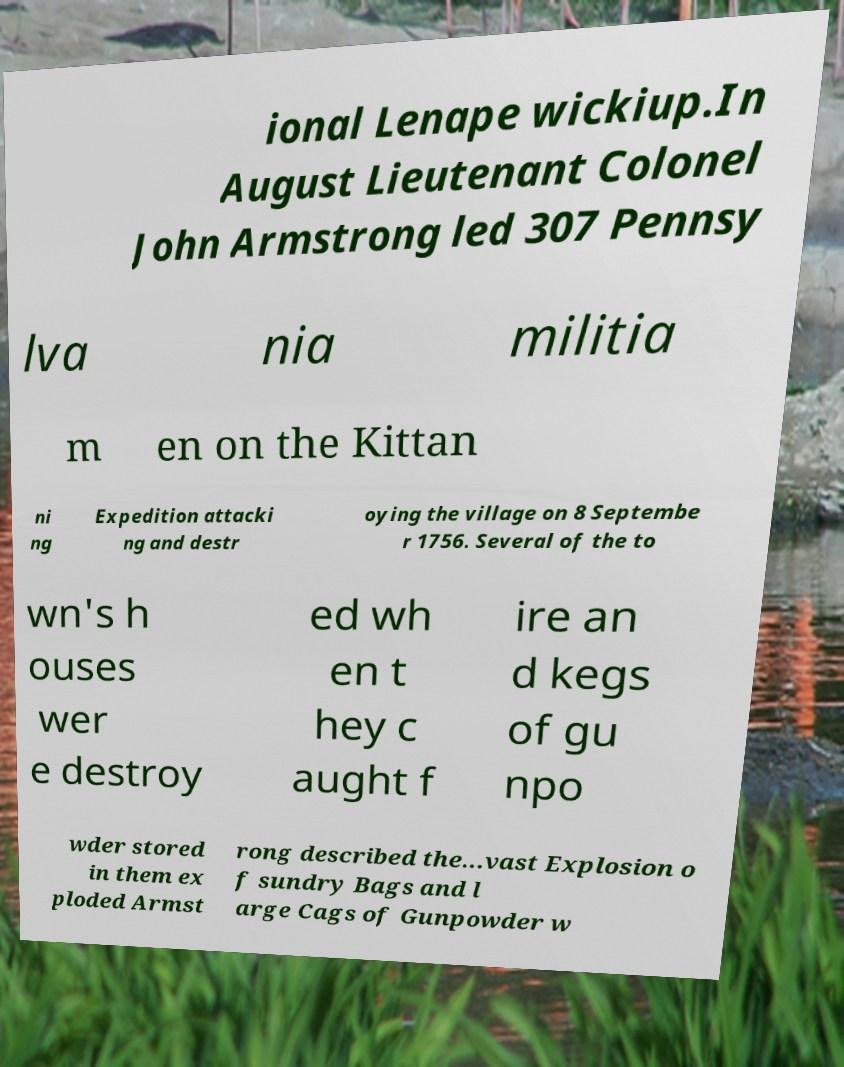Can you read and provide the text displayed in the image?This photo seems to have some interesting text. Can you extract and type it out for me? ional Lenape wickiup.In August Lieutenant Colonel John Armstrong led 307 Pennsy lva nia militia m en on the Kittan ni ng Expedition attacki ng and destr oying the village on 8 Septembe r 1756. Several of the to wn's h ouses wer e destroy ed wh en t hey c aught f ire an d kegs of gu npo wder stored in them ex ploded Armst rong described the...vast Explosion o f sundry Bags and l arge Cags of Gunpowder w 